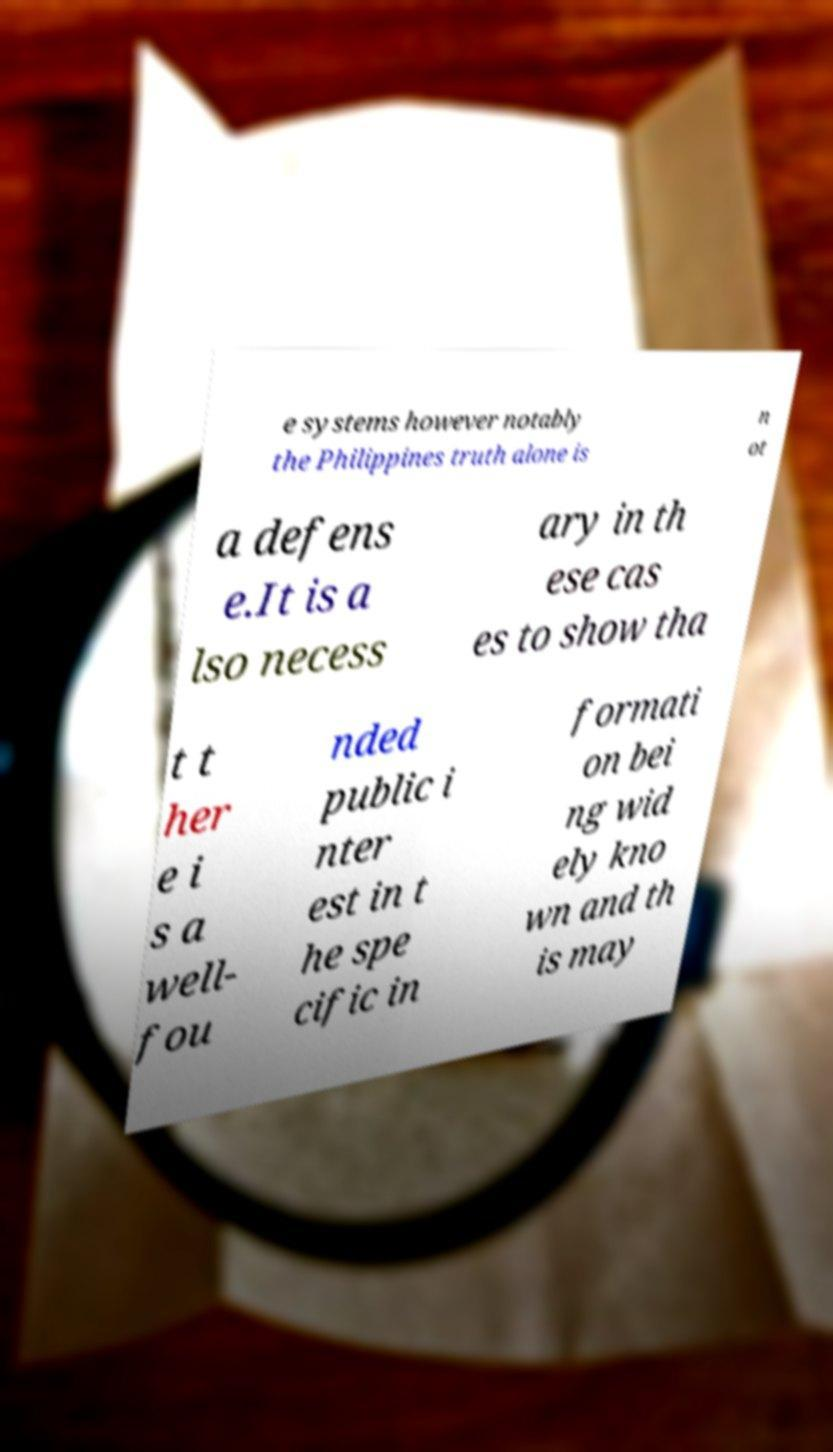Could you assist in decoding the text presented in this image and type it out clearly? e systems however notably the Philippines truth alone is n ot a defens e.It is a lso necess ary in th ese cas es to show tha t t her e i s a well- fou nded public i nter est in t he spe cific in formati on bei ng wid ely kno wn and th is may 